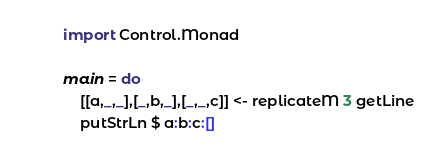<code> <loc_0><loc_0><loc_500><loc_500><_Haskell_>import Control.Monad

main = do
    [[a,_,_],[_,b,_],[_,_,c]] <- replicateM 3 getLine
    putStrLn $ a:b:c:[] </code> 